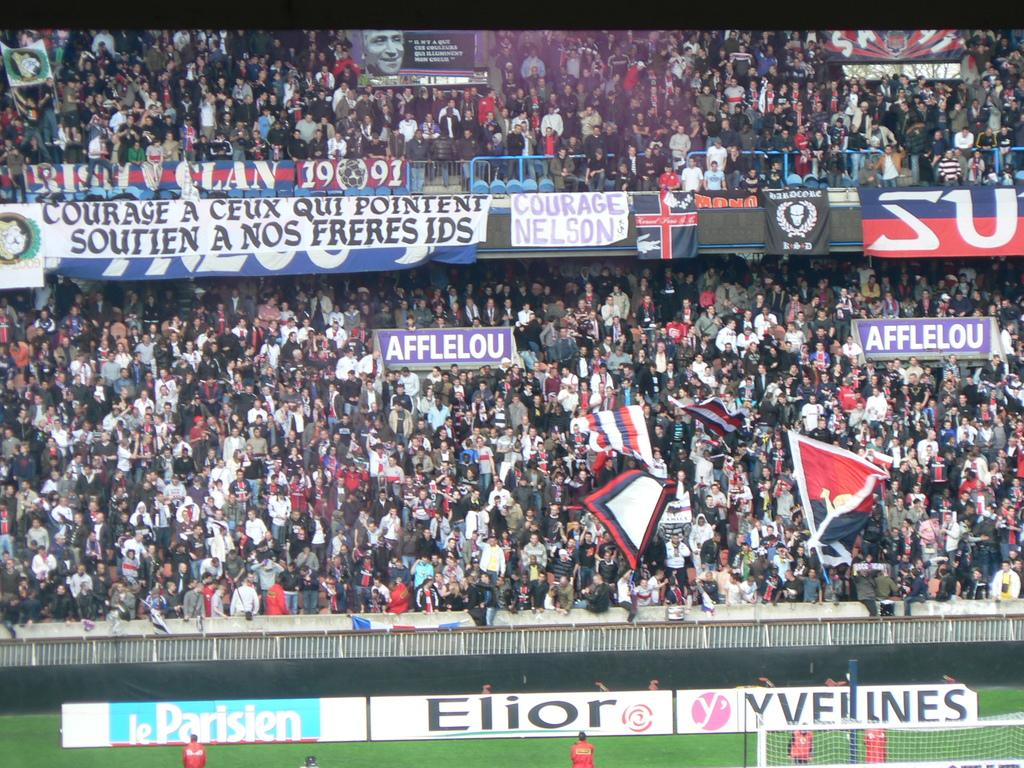<image>
Create a compact narrative representing the image presented. People in the crowd are holding banners that say Afflelou at this sporting event. 